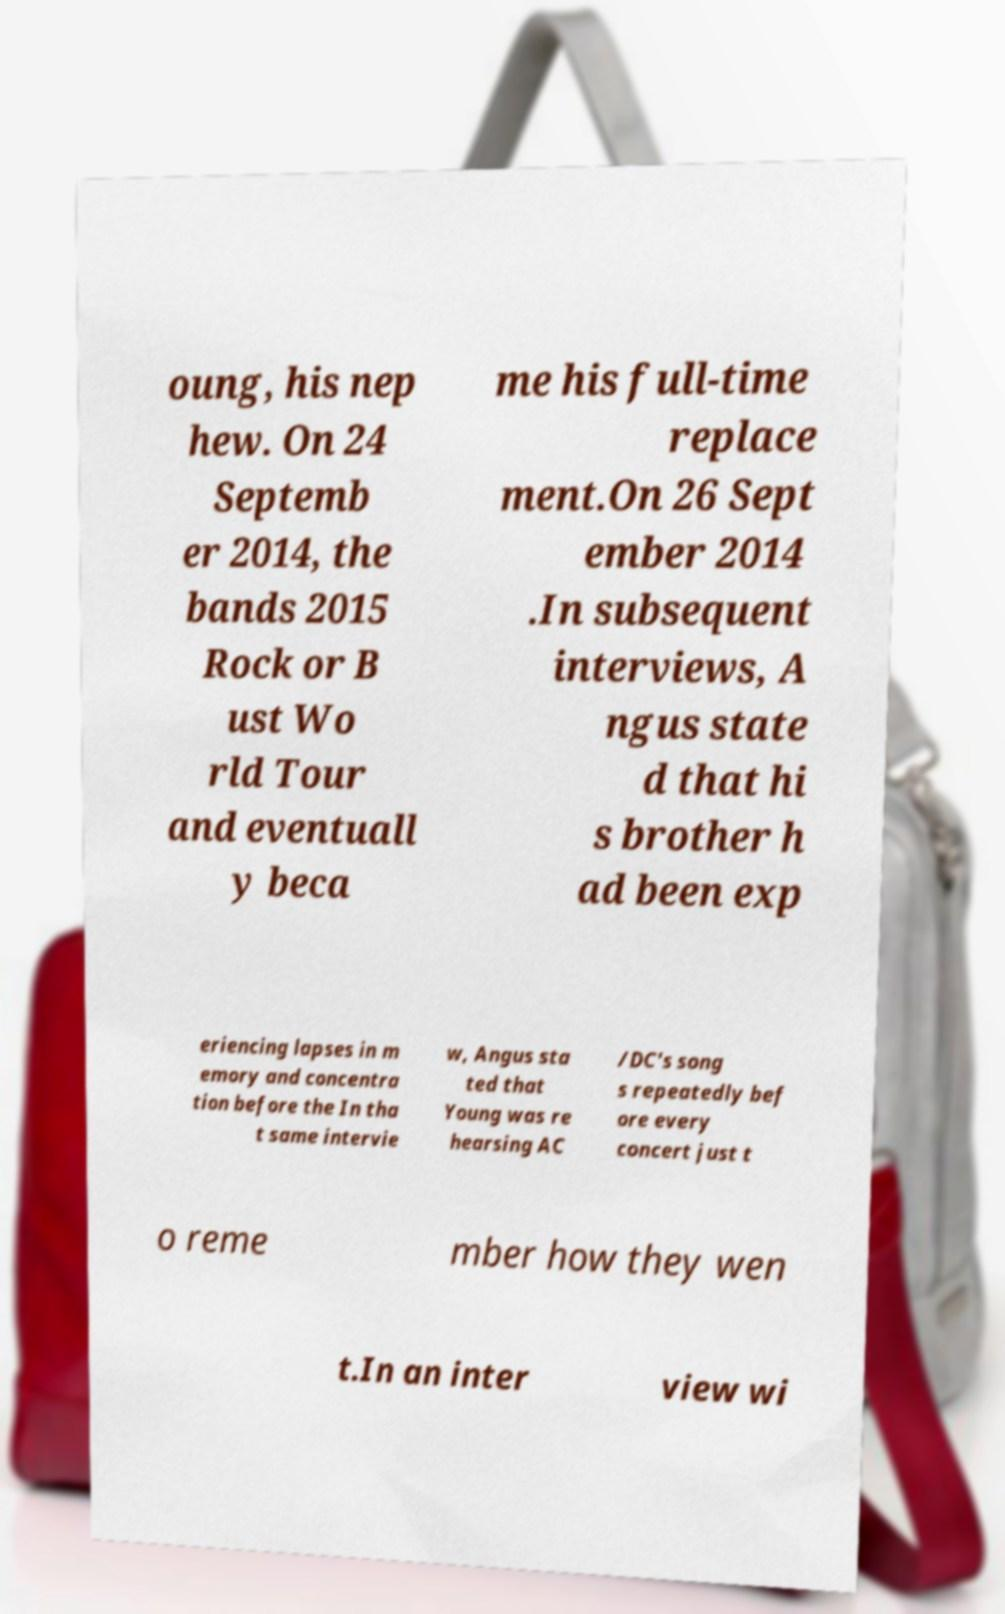What messages or text are displayed in this image? I need them in a readable, typed format. oung, his nep hew. On 24 Septemb er 2014, the bands 2015 Rock or B ust Wo rld Tour and eventuall y beca me his full-time replace ment.On 26 Sept ember 2014 .In subsequent interviews, A ngus state d that hi s brother h ad been exp eriencing lapses in m emory and concentra tion before the In tha t same intervie w, Angus sta ted that Young was re hearsing AC /DC's song s repeatedly bef ore every concert just t o reme mber how they wen t.In an inter view wi 